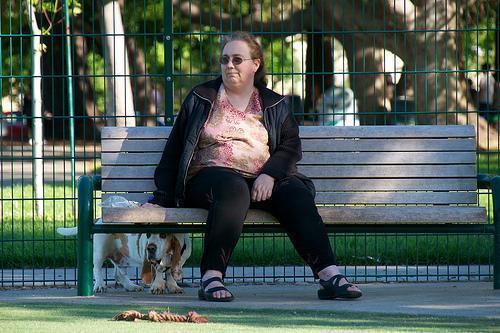How many dogs are there?
Give a very brief answer. 1. How many people are in this photo?
Give a very brief answer. 1. 